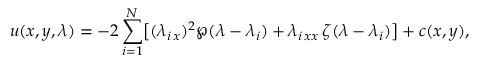<formula> <loc_0><loc_0><loc_500><loc_500>u ( x , y , \lambda ) = - 2 \sum _ { i = 1 } ^ { N } \left [ ( \lambda _ { i \, x } ) ^ { 2 } \wp ( \lambda - \lambda _ { i } ) + \lambda _ { i \, x x } \, \zeta ( \lambda - \lambda _ { i } ) \right ] + c ( x , y ) ,</formula> 